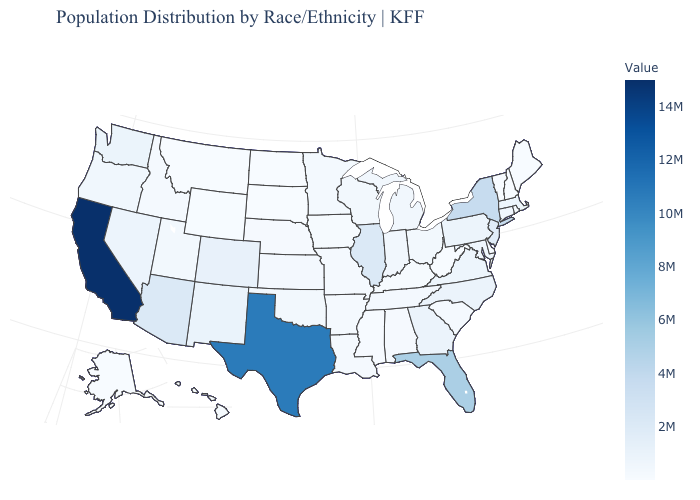Does California have the highest value in the West?
Write a very short answer. Yes. Does Louisiana have the highest value in the USA?
Write a very short answer. No. Which states have the lowest value in the USA?
Write a very short answer. Vermont. 